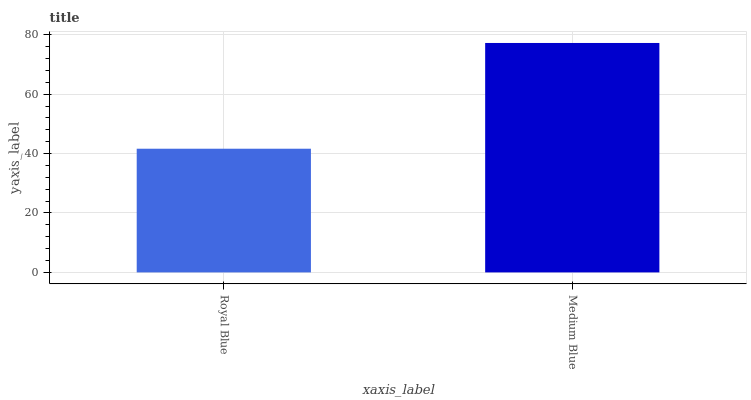Is Royal Blue the minimum?
Answer yes or no. Yes. Is Medium Blue the maximum?
Answer yes or no. Yes. Is Medium Blue the minimum?
Answer yes or no. No. Is Medium Blue greater than Royal Blue?
Answer yes or no. Yes. Is Royal Blue less than Medium Blue?
Answer yes or no. Yes. Is Royal Blue greater than Medium Blue?
Answer yes or no. No. Is Medium Blue less than Royal Blue?
Answer yes or no. No. Is Medium Blue the high median?
Answer yes or no. Yes. Is Royal Blue the low median?
Answer yes or no. Yes. Is Royal Blue the high median?
Answer yes or no. No. Is Medium Blue the low median?
Answer yes or no. No. 